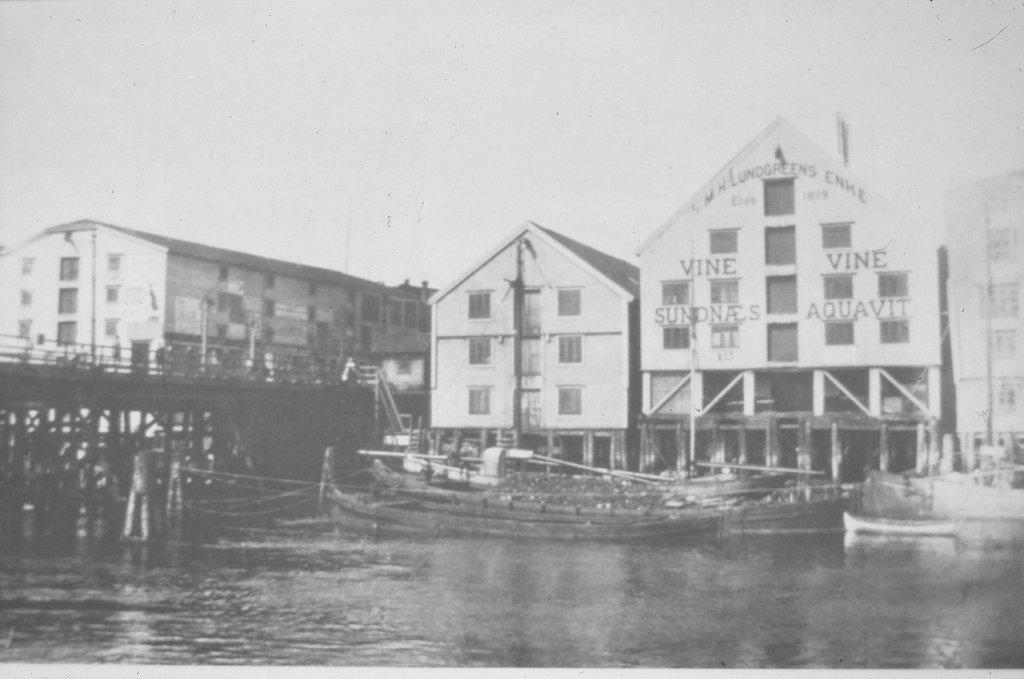What is the color scheme of the image? The image is in black and white. What structures can be seen in the image? There are multiple buildings in the image. What natural feature is present in front of the buildings? There is a lake in front of the buildings. What type of transportation can be seen in the lake? Boats are present in the lake. Where is the bridge located in the image? The bridge is to the left side of the image. What type of spot can be seen on the roof of the building in the image? There is no spot visible on the roof of the building in the image, as the image is in black and white and does not show any spots. What type of quill is used by the birds flying over the bridge in the image? There are no birds or quills present in the image. 